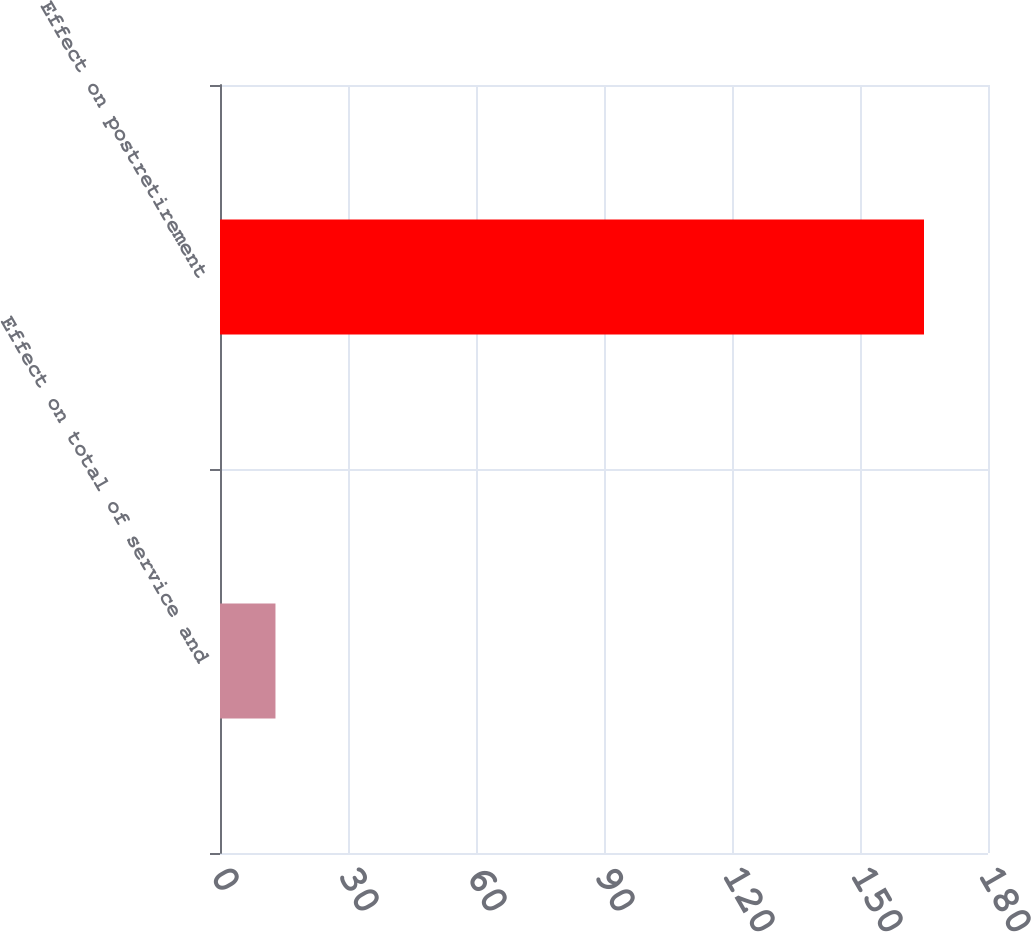<chart> <loc_0><loc_0><loc_500><loc_500><bar_chart><fcel>Effect on total of service and<fcel>Effect on postretirement<nl><fcel>13<fcel>165<nl></chart> 